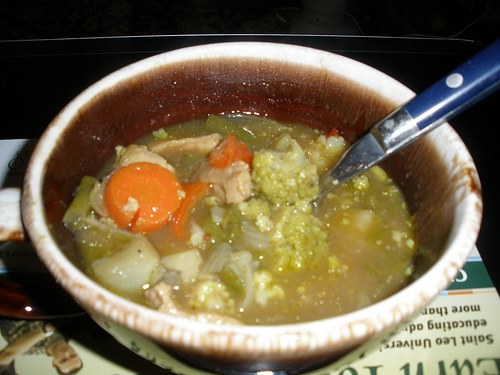Are there onions or eggs in the photograph? Yes, there are onions in the photograph. Eggs are not visible. 